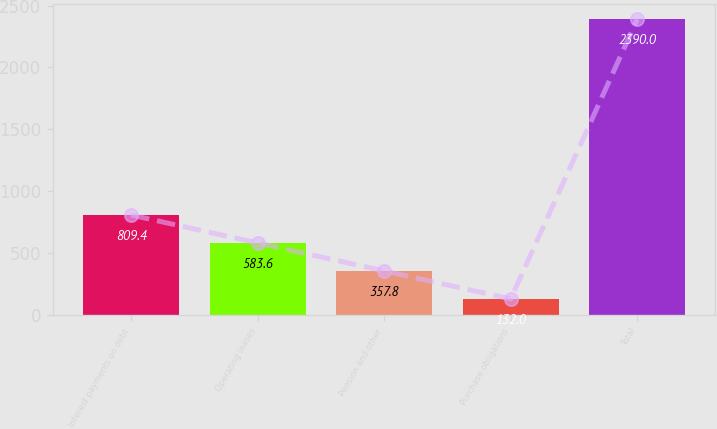Convert chart. <chart><loc_0><loc_0><loc_500><loc_500><bar_chart><fcel>Interest payments on debt<fcel>Operating leases<fcel>Pension and other<fcel>Purchase obligations<fcel>Total<nl><fcel>809.4<fcel>583.6<fcel>357.8<fcel>132<fcel>2390<nl></chart> 